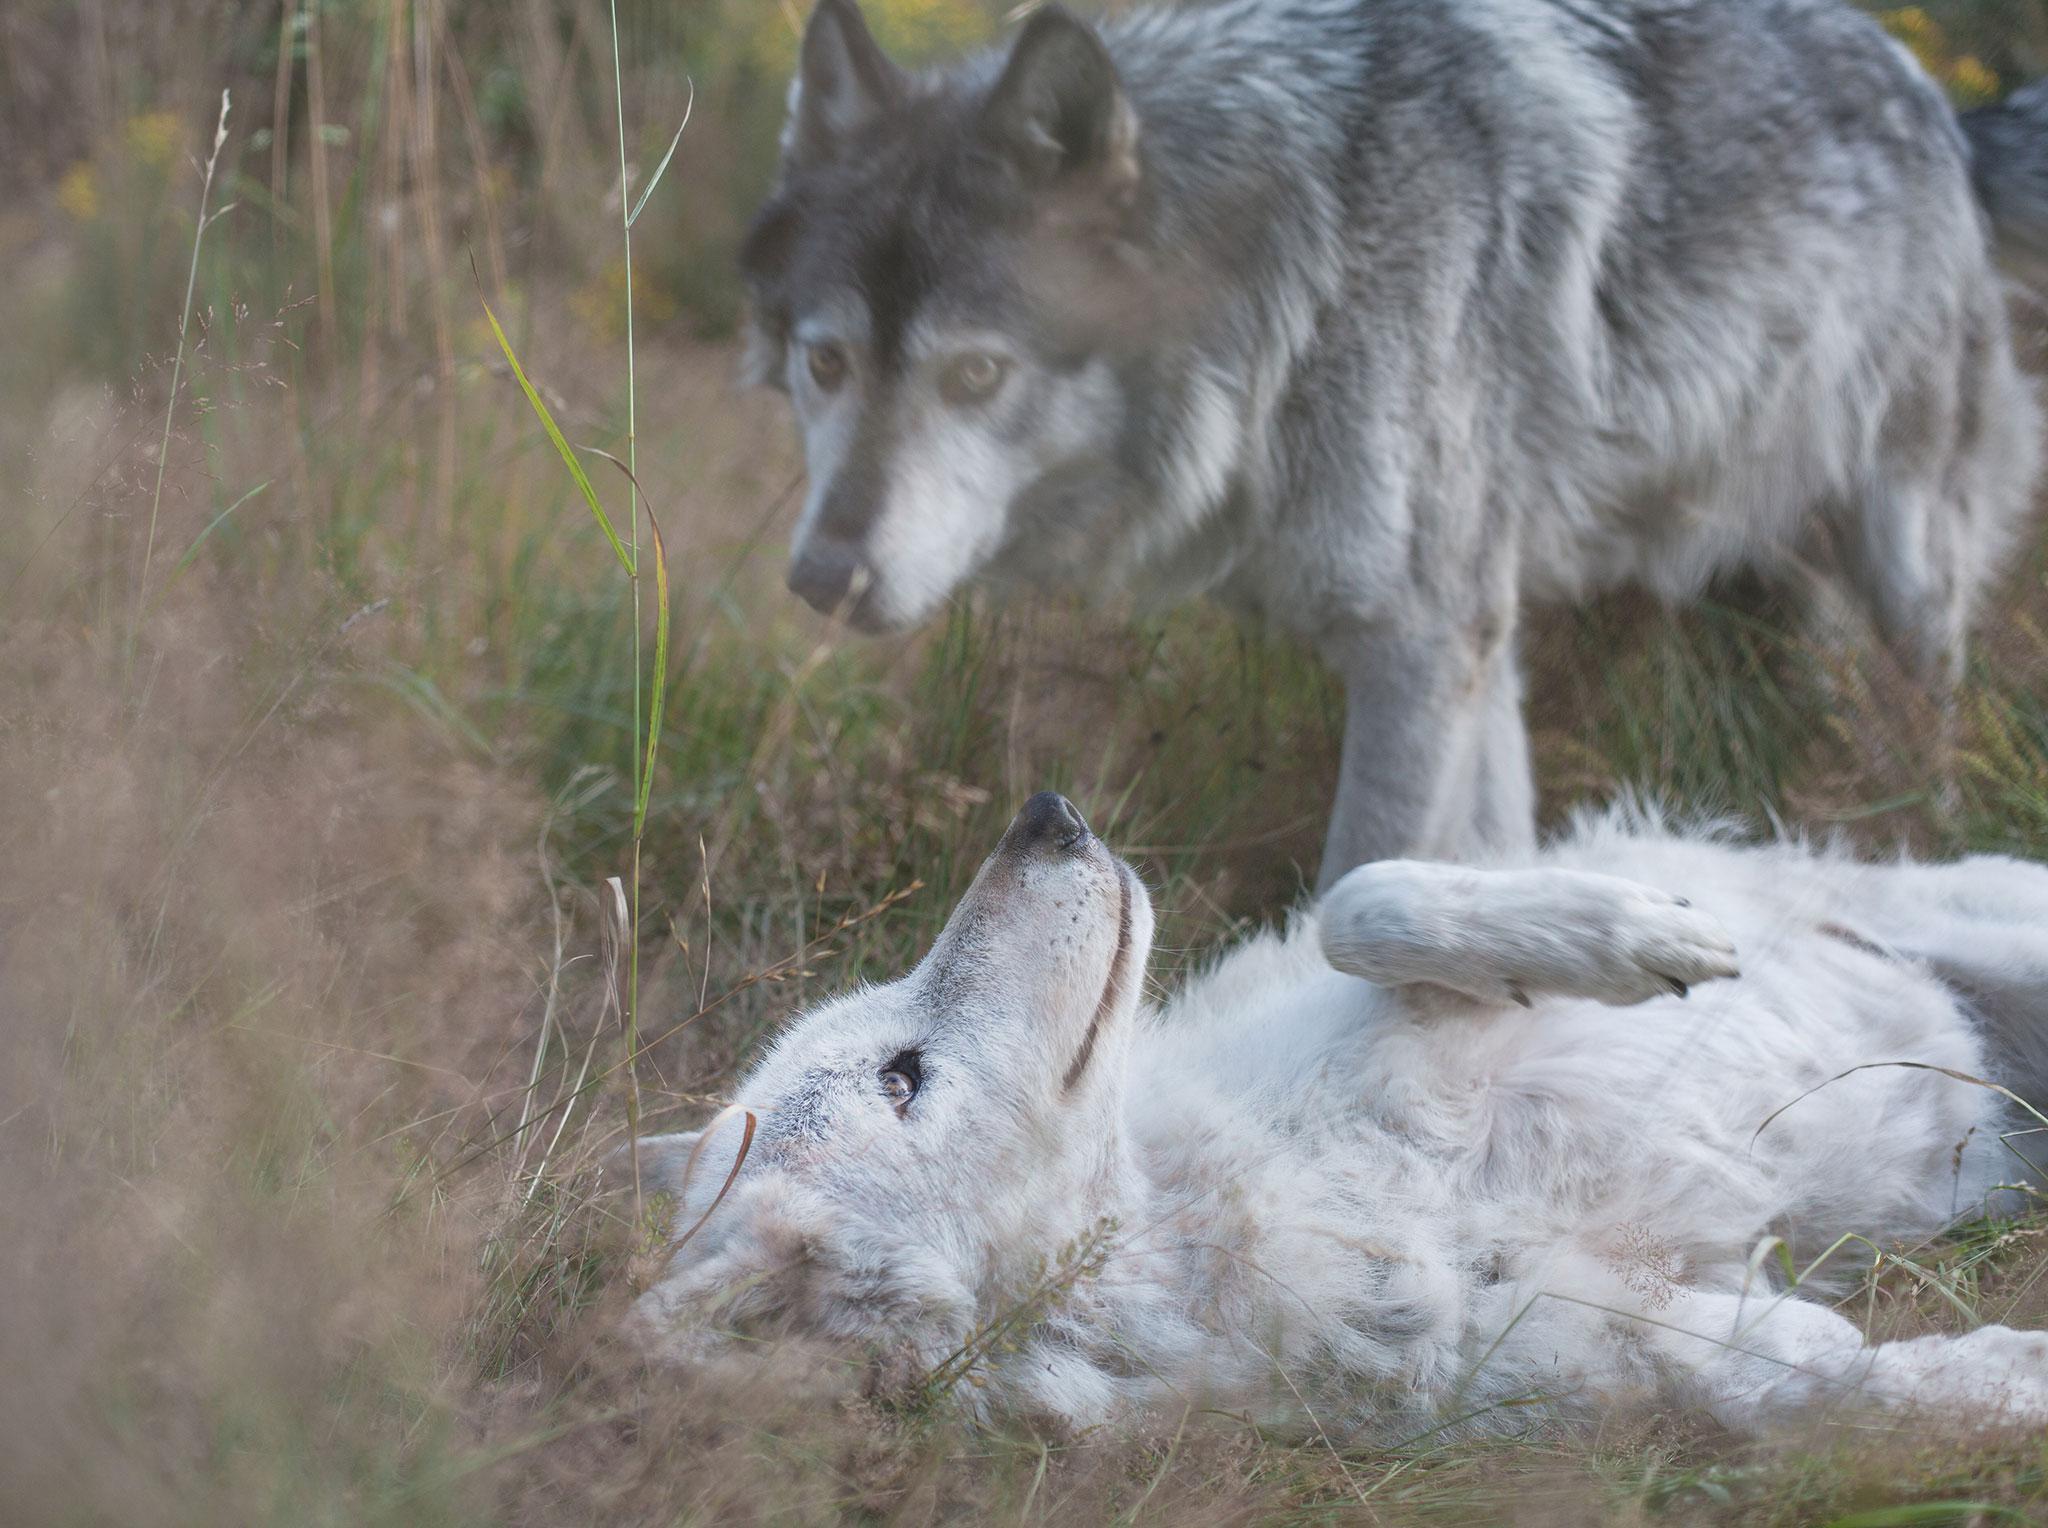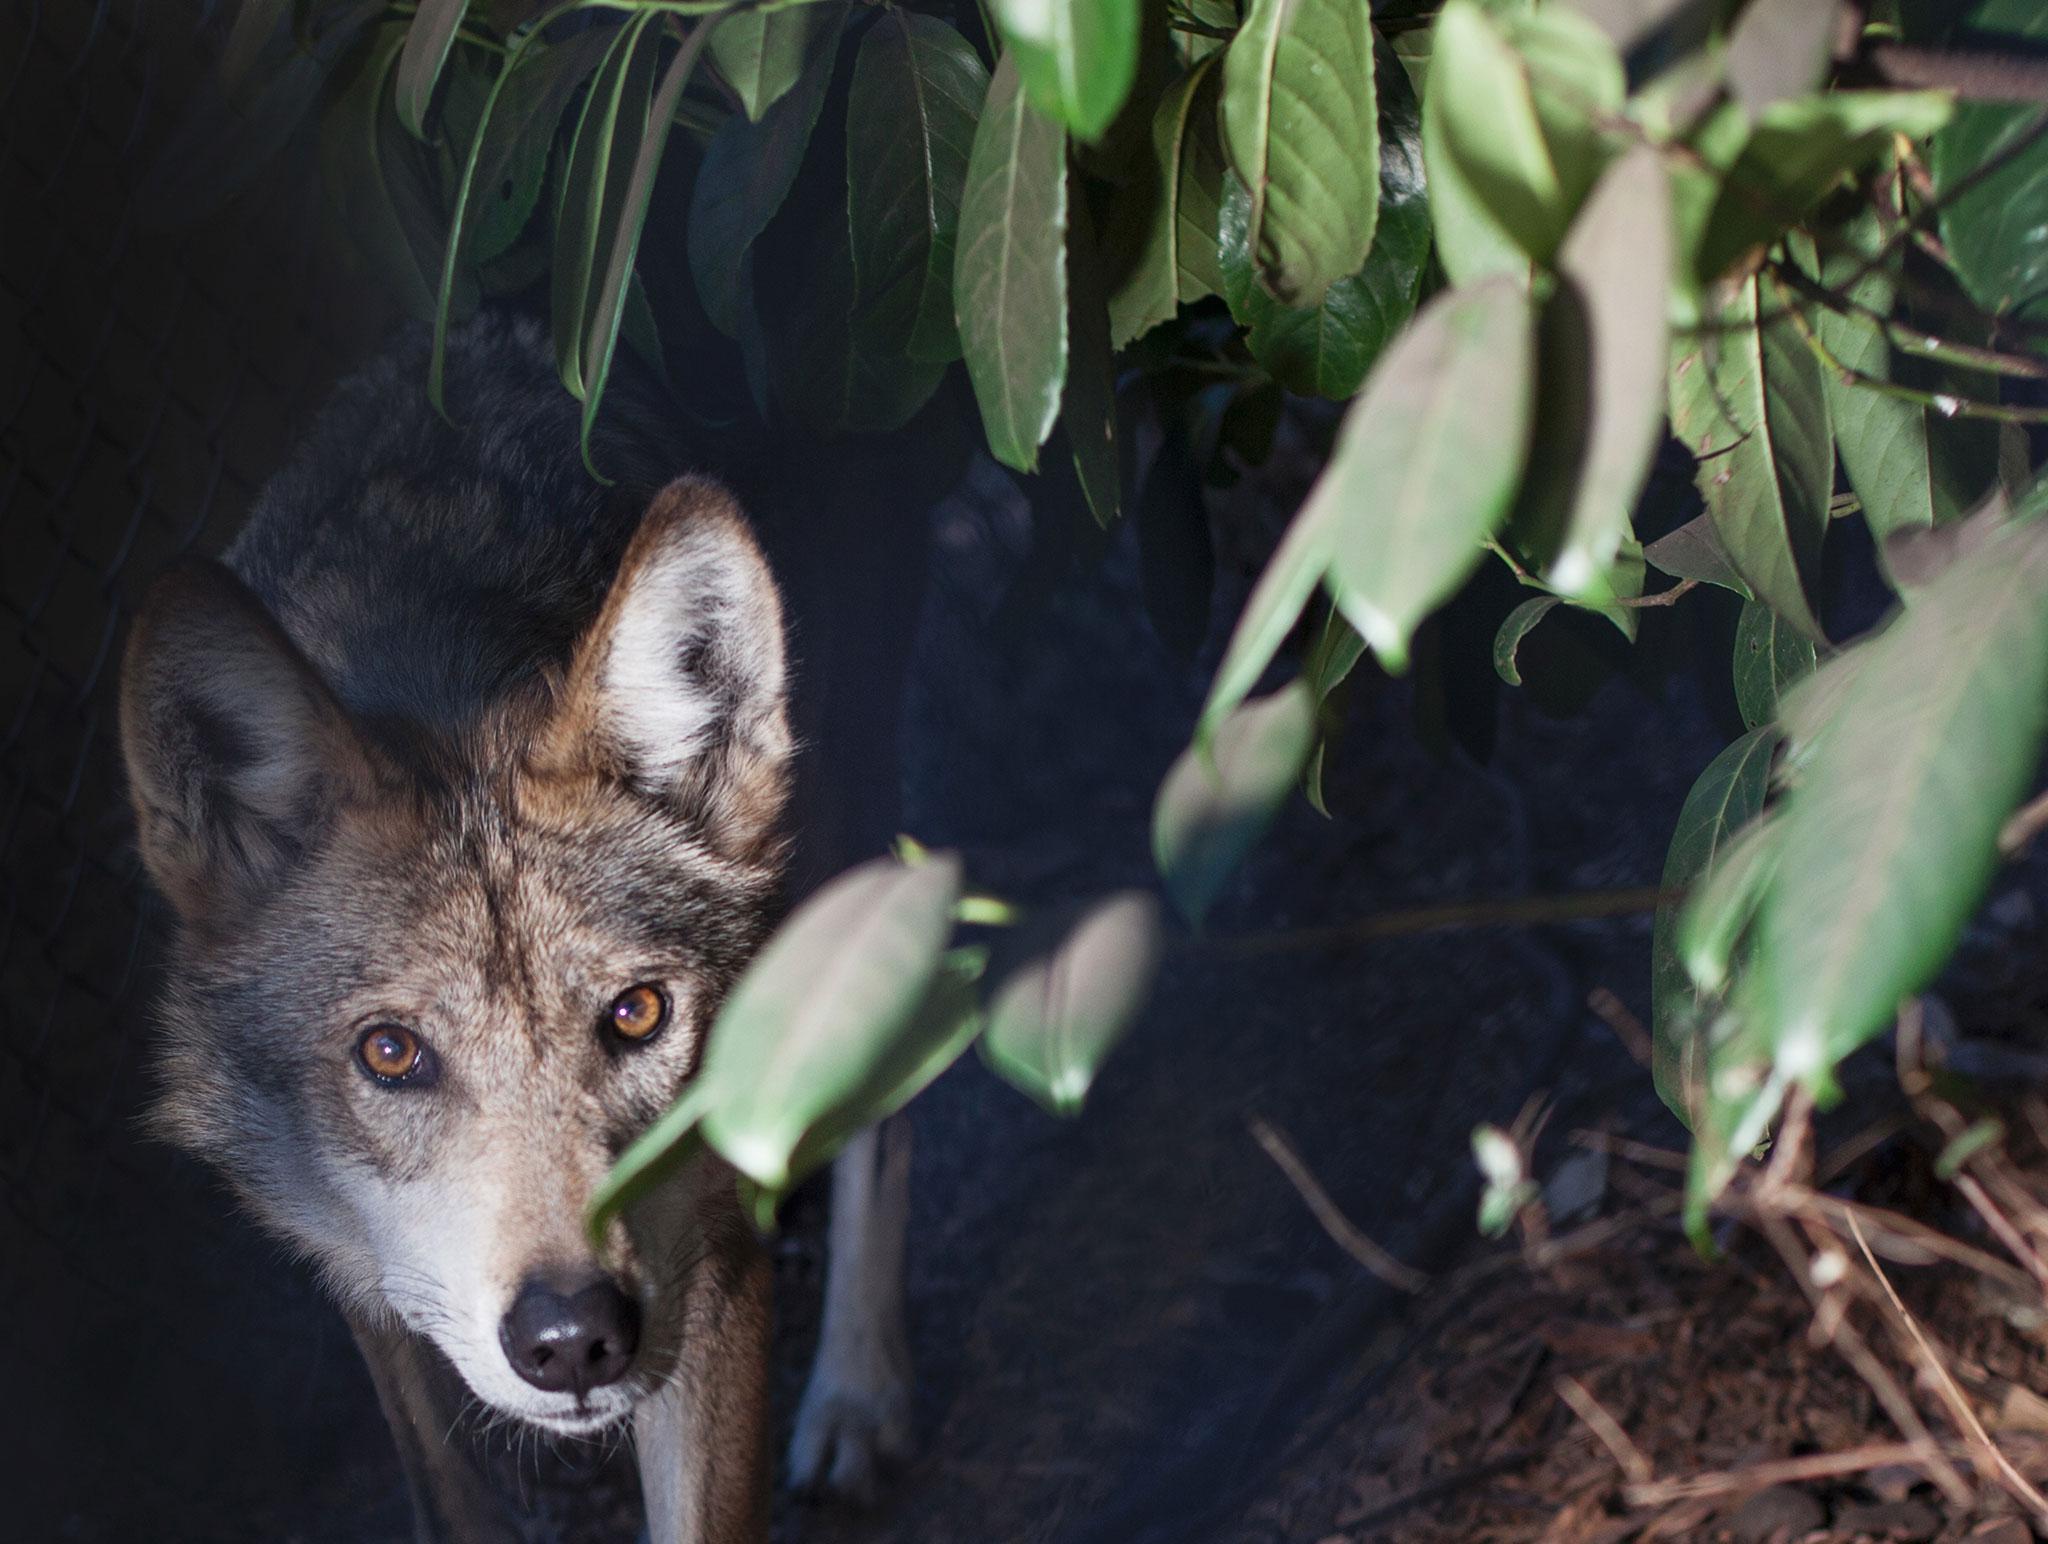The first image is the image on the left, the second image is the image on the right. Given the left and right images, does the statement "In the center of each image a wolf can be seen in the outdoors." hold true? Answer yes or no. No. The first image is the image on the left, the second image is the image on the right. For the images displayed, is the sentence "Each image contains one forward-turned wolf with its head held straight and level, and the gazes of the wolves on the right and left are aimed in the same direction." factually correct? Answer yes or no. No. 